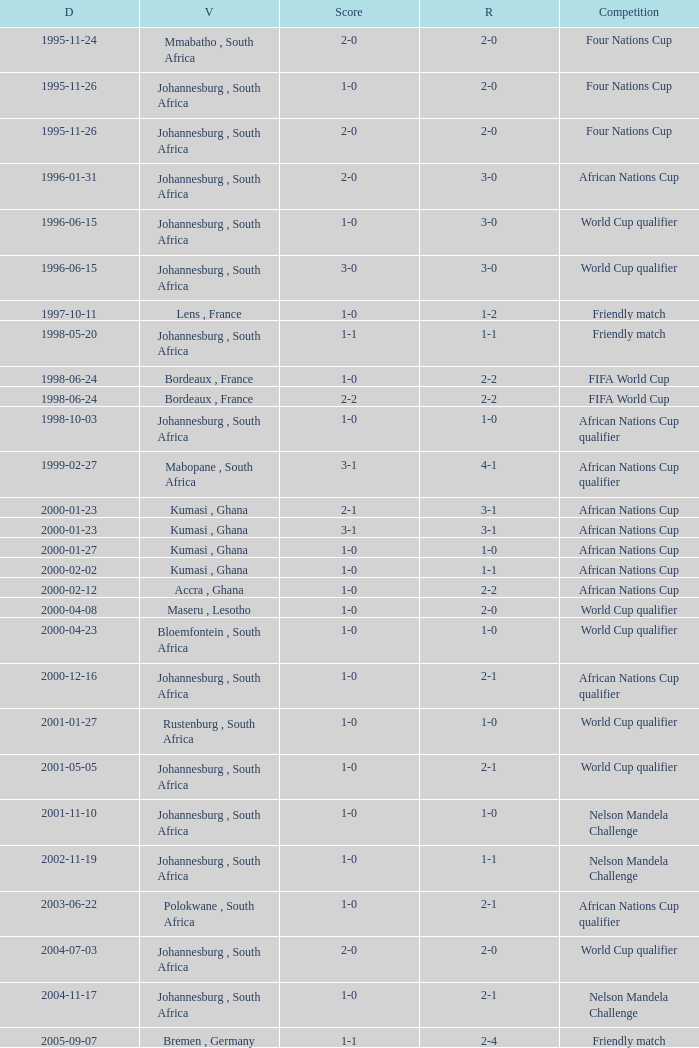What is the Date of the Fifa World Cup with a Score of 1-0? 1998-06-24. 